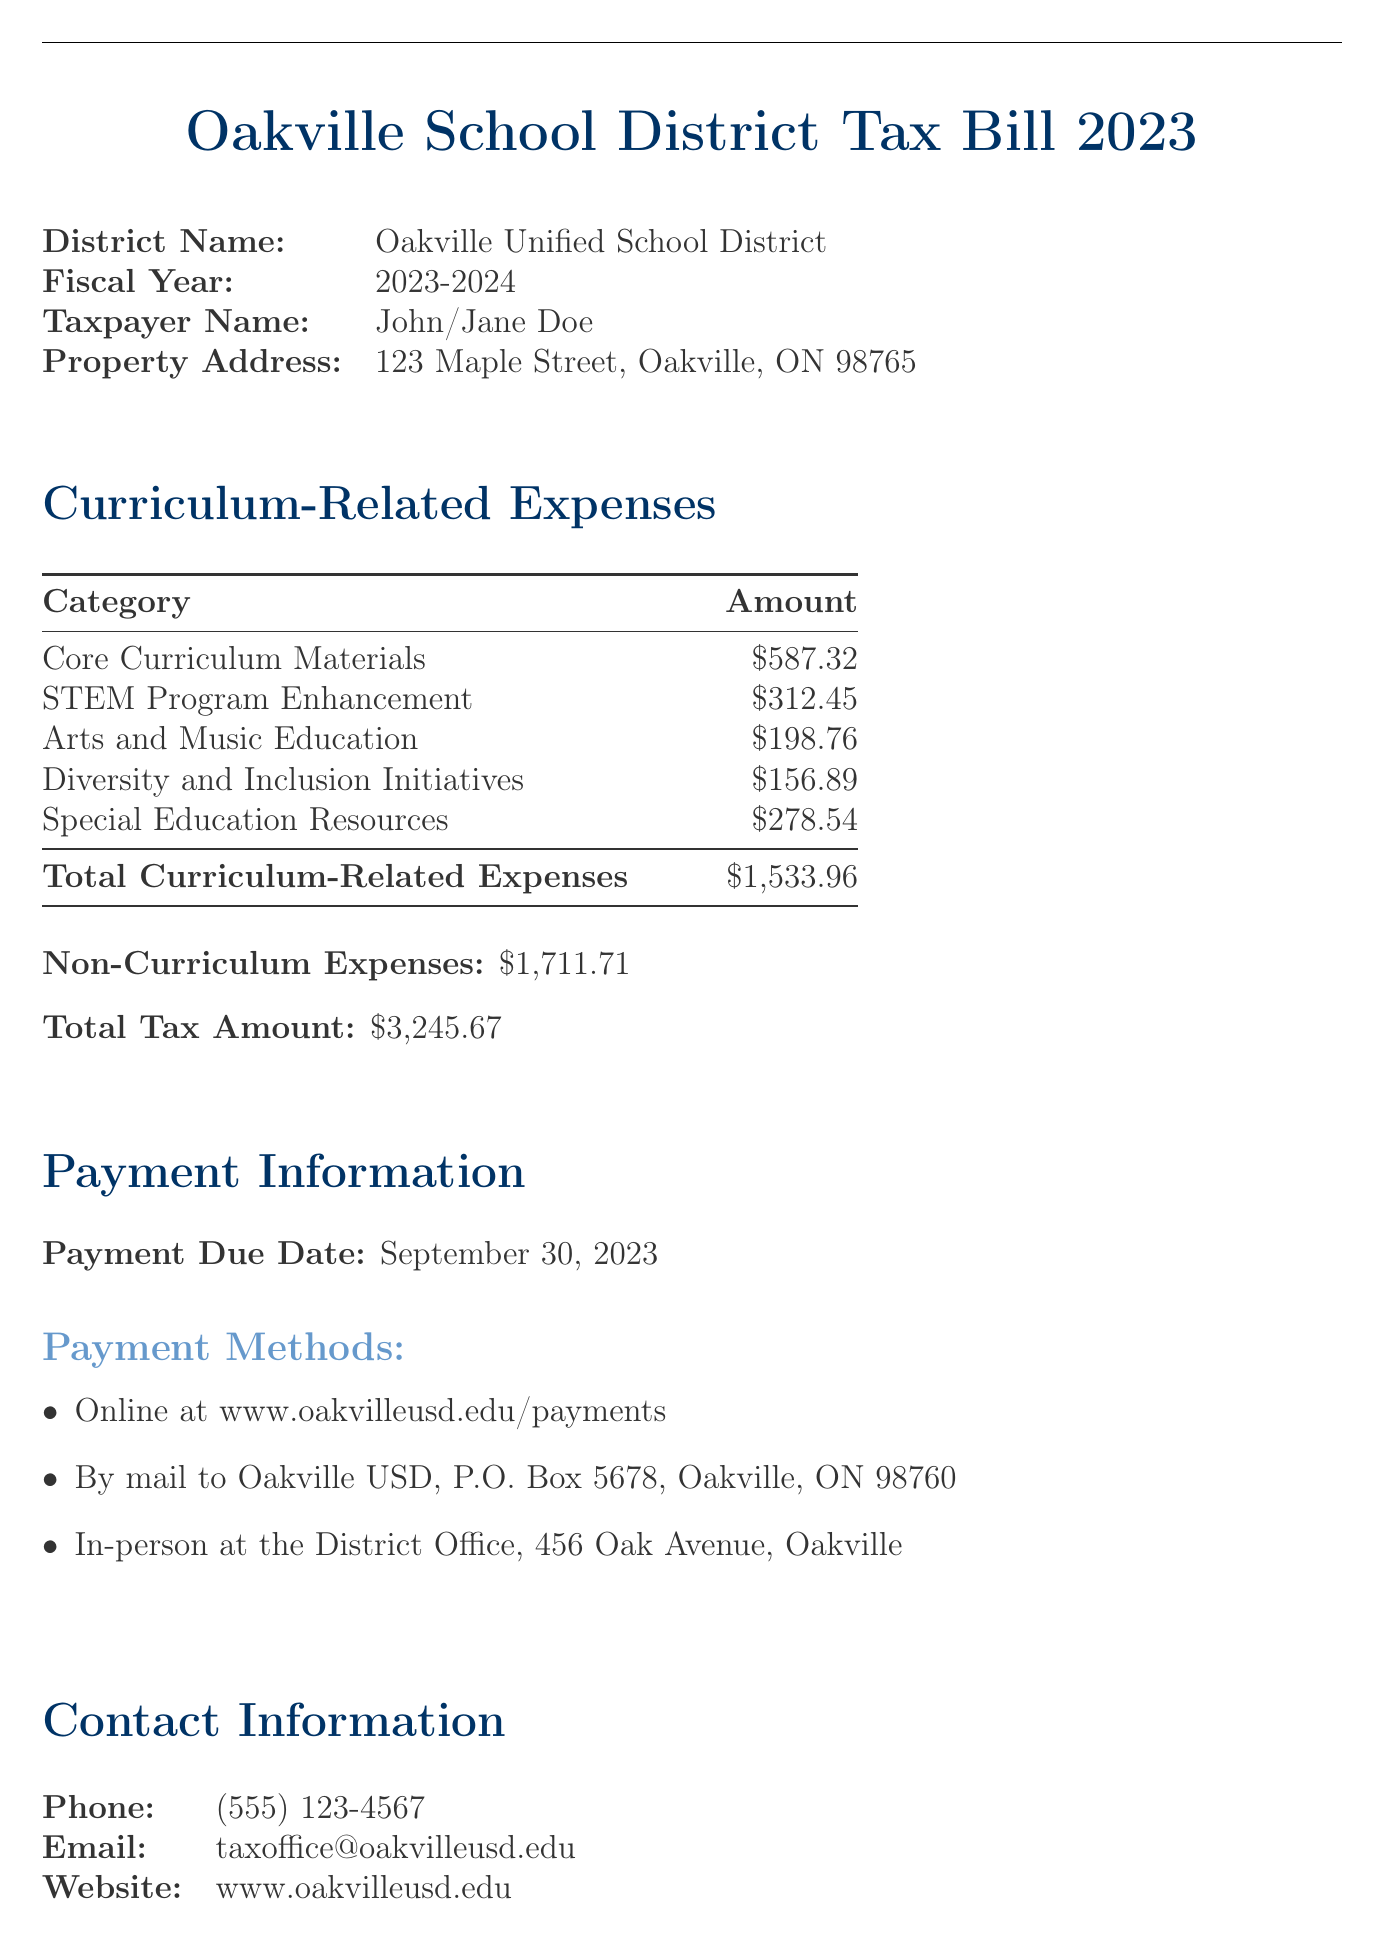What is the total tax amount? The total tax amount is stated clearly in the document.
Answer: $3,245.67 What is the payment due date? The payment due date provides a specific date by which the tax should be paid.
Answer: September 30, 2023 How much is allocated for core curriculum materials? The amount for core curriculum materials is listed under the curriculum-related expenses section.
Answer: $587.32 What is the total amount for curriculum-related expenses? The total for curriculum-related expenses is provided at the bottom of that section.
Answer: $1,533.96 What are the non-curriculum expenses? The document separates curriculum-related and non-curriculum expenses, and the total for non-curriculum expenses is listed.
Answer: $1,711.71 How much is allocated to diversity and inclusion initiatives? This specific amount is found in the curriculum-related expenses category listed in the document.
Answer: $156.89 What is the category that has the least funding? The categories in curriculum-related expenses can be compared to find which has the least funding.
Answer: Arts and Music Education What is the taxpayer's property address? The document contains details about the taxpayer, including their property address.
Answer: 123 Maple Street, Oakville, ON 98765 Who should be contacted for questions regarding the tax bill? The contact information provided in the document indicates who to reach out to for questions.
Answer: taxoffice@oakvilleusd.edu 